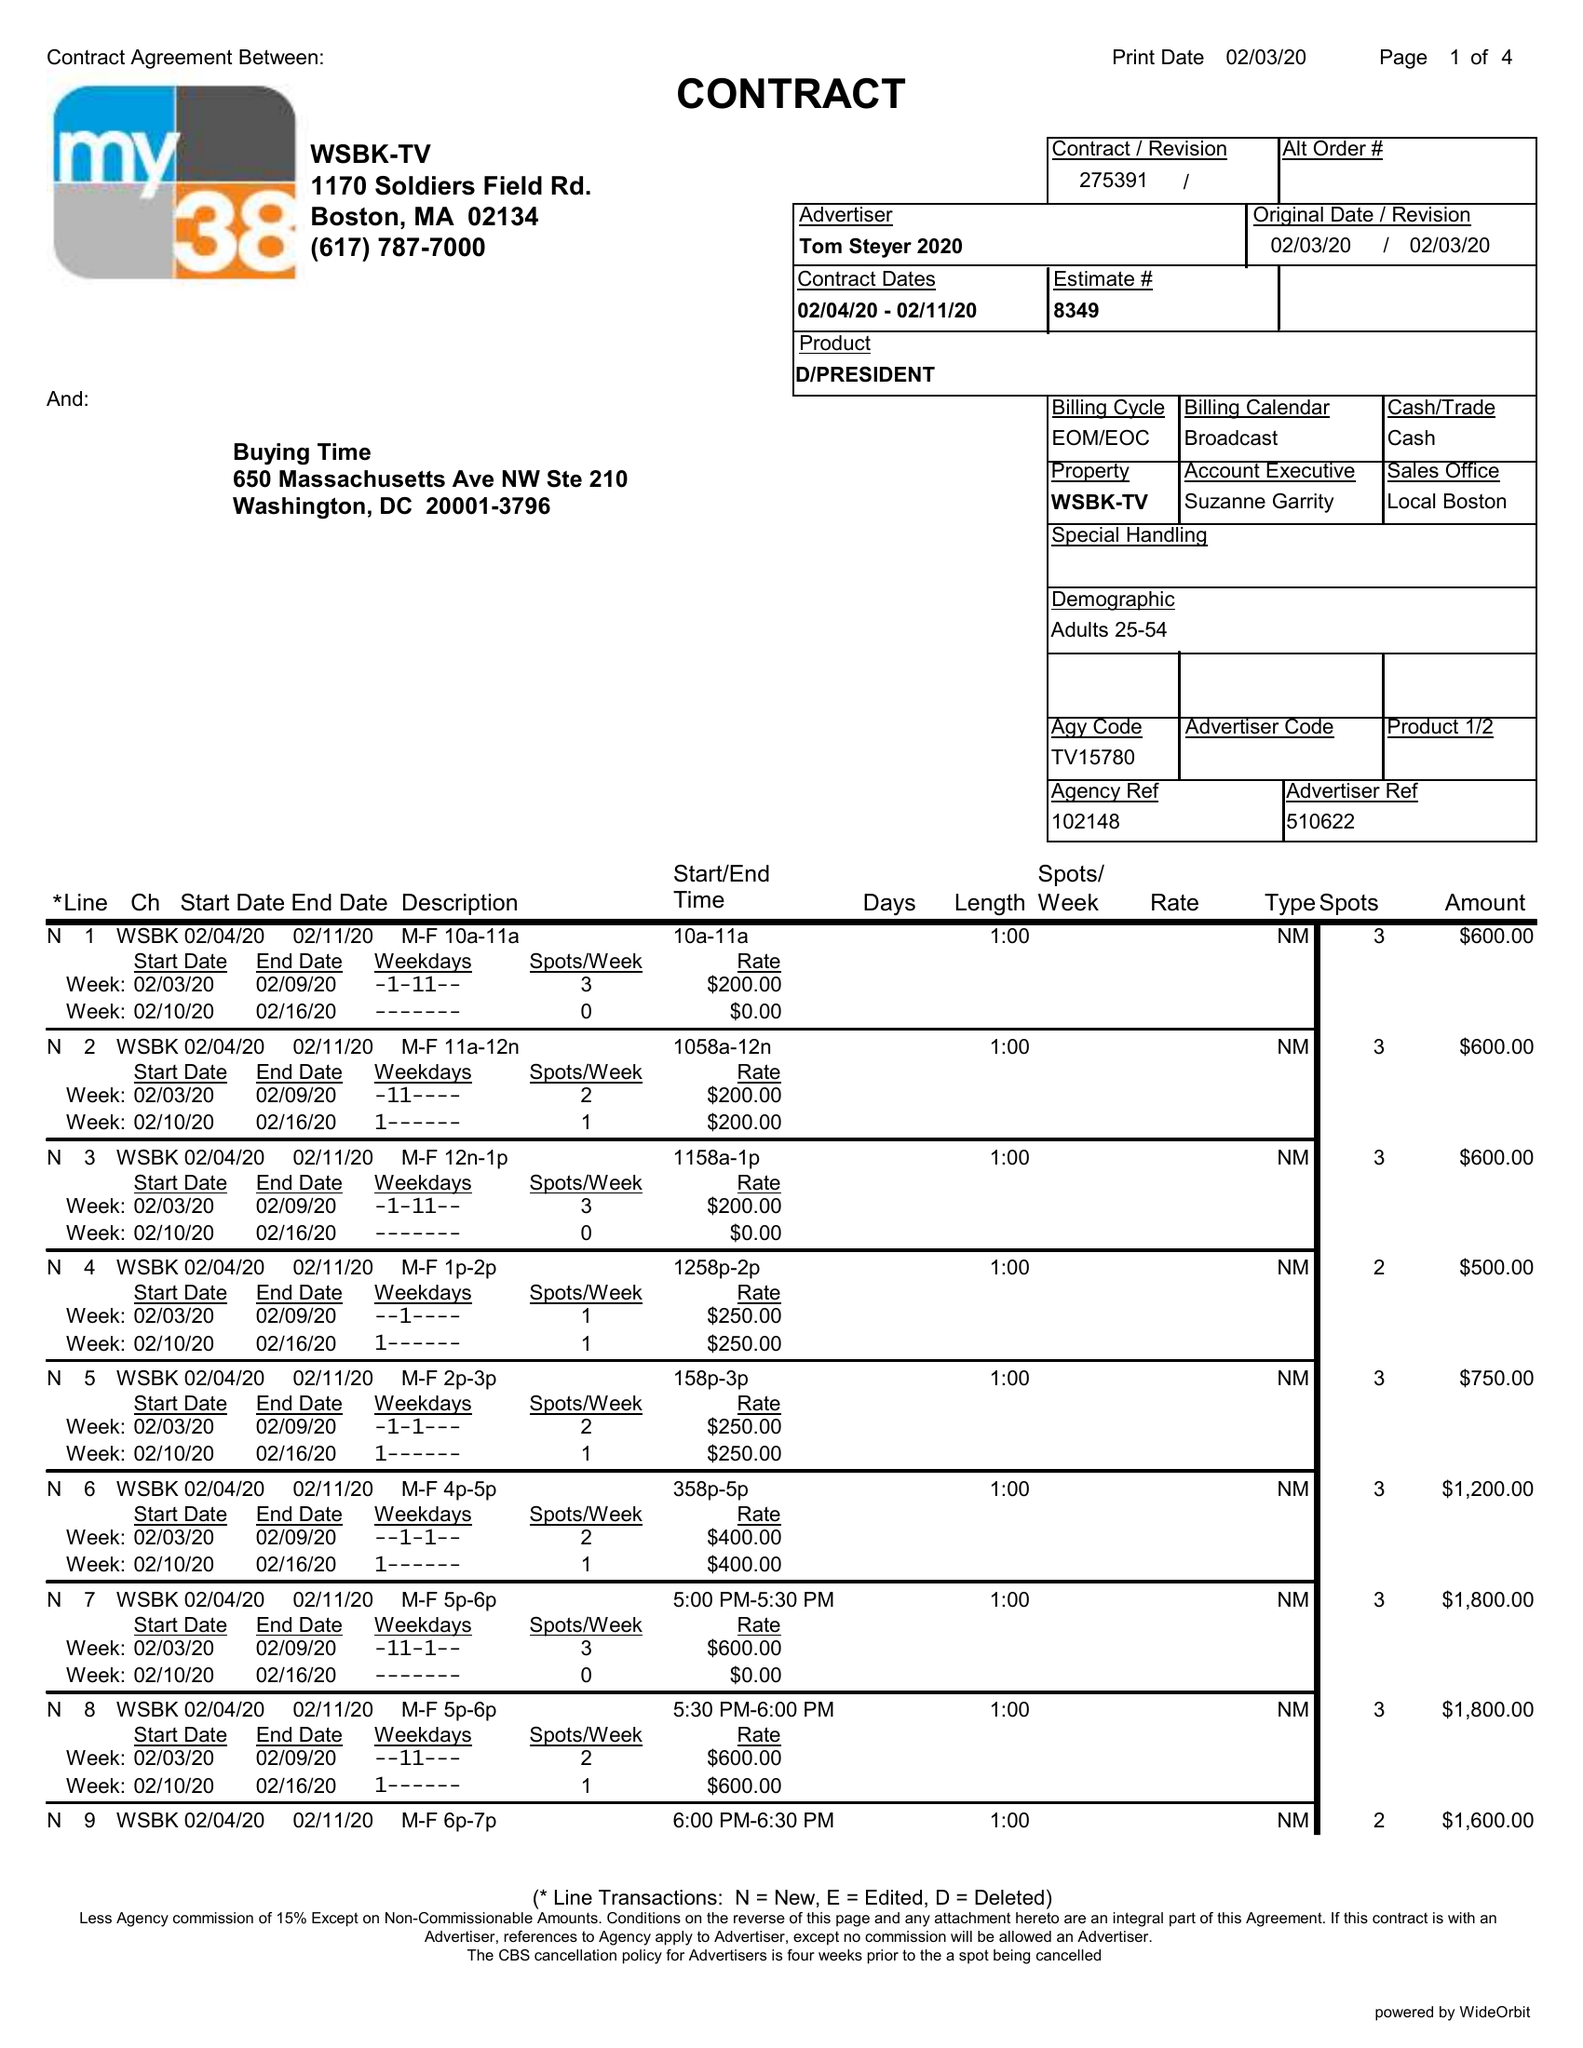What is the value for the advertiser?
Answer the question using a single word or phrase. TOM STEYER 2020 